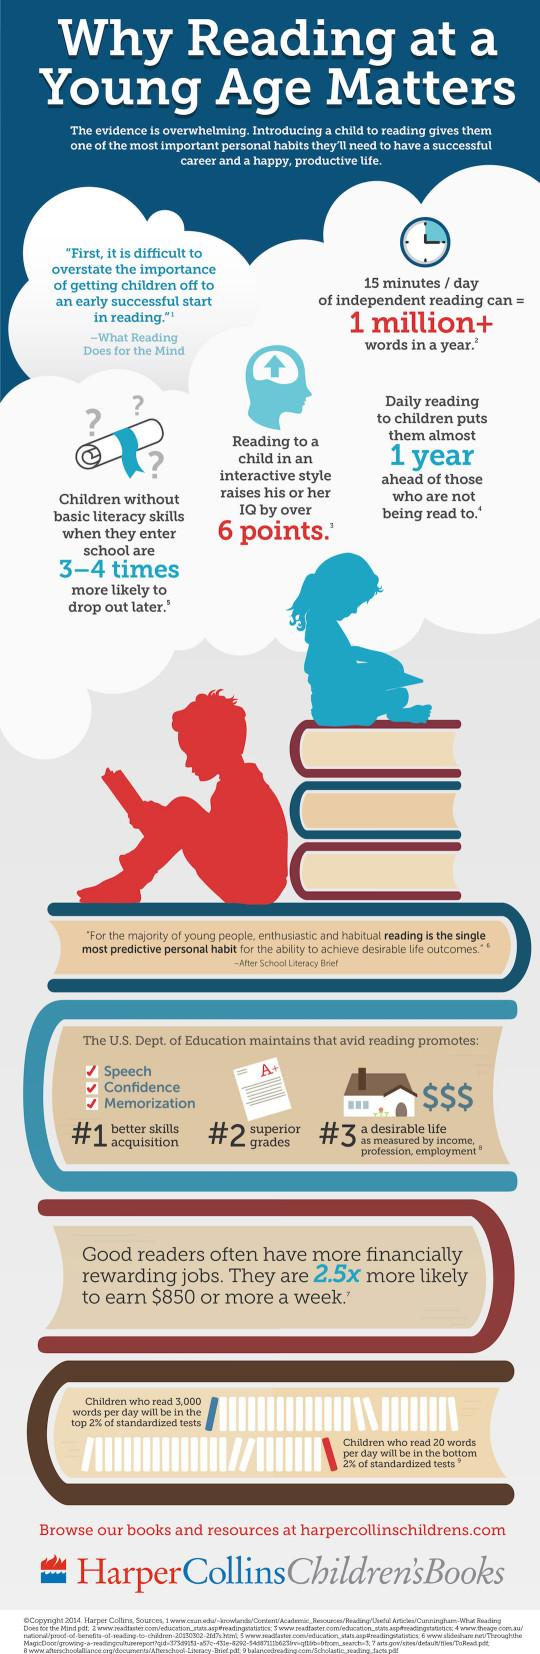Mention a couple of crucial points in this snapshot. The color of the icon of the boy shown is red. 